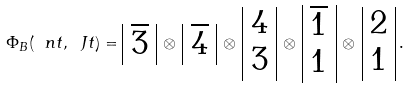<formula> <loc_0><loc_0><loc_500><loc_500>\Phi _ { B } ( \ n t , \ J t ) = \begin{array} { | c | } \overline { 3 } \\ \end{array} \, \otimes \, \begin{array} { | c | } \overline { 4 } \\ \end{array} \, \otimes \, \begin{array} { | c | } 4 \\ 3 \\ \end{array} \, \otimes \, \begin{array} { | c | } \overline { 1 } \\ 1 \\ \end{array} \, \otimes \, \begin{array} { | c | } 2 \\ 1 \\ \end{array} \, .</formula> 